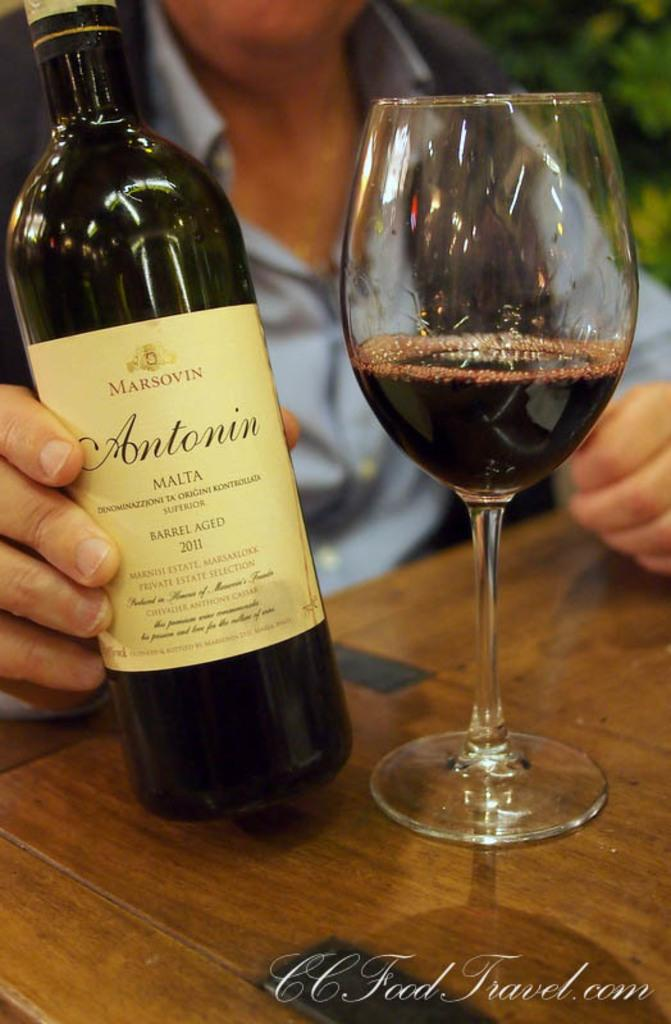<image>
Offer a succinct explanation of the picture presented. Someone is holding a bottle of Antonin Malta next to a wine glass. 